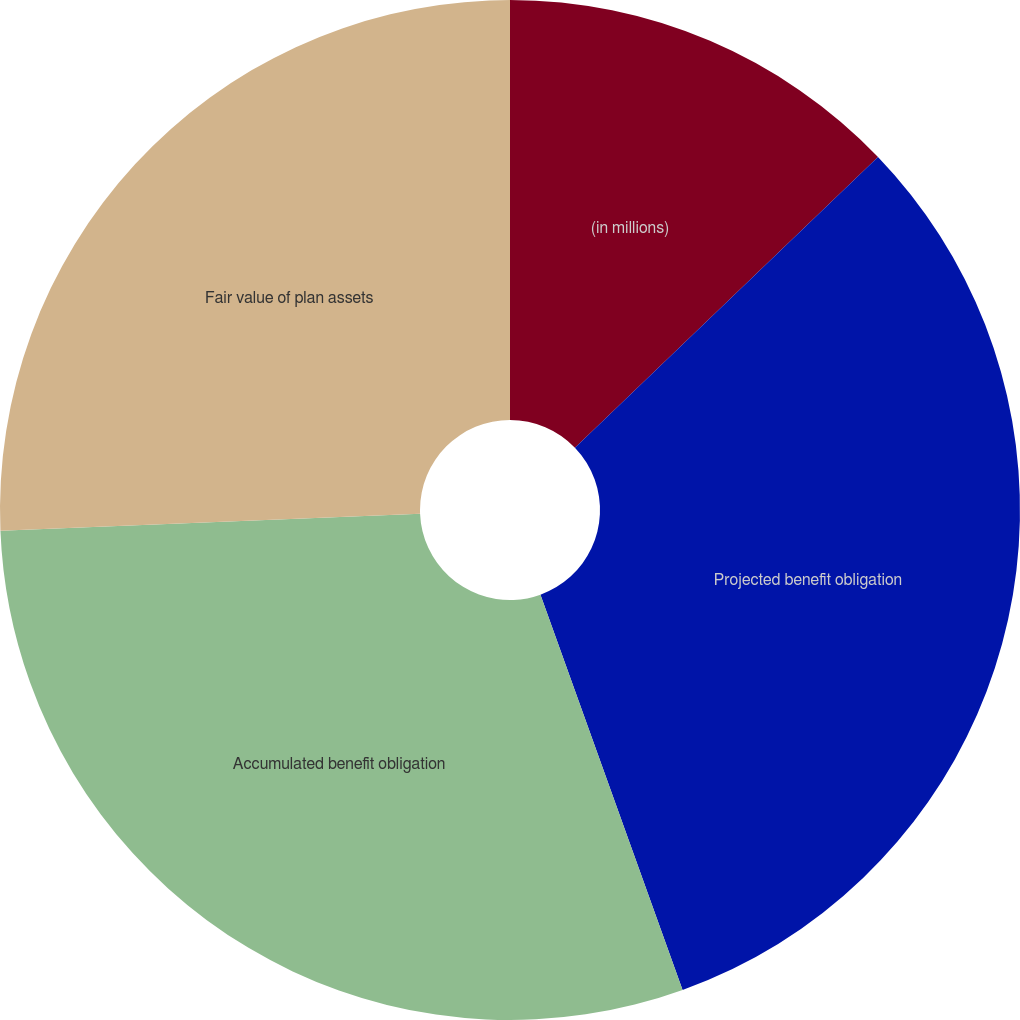Convert chart to OTSL. <chart><loc_0><loc_0><loc_500><loc_500><pie_chart><fcel>(in millions)<fcel>Projected benefit obligation<fcel>Accumulated benefit obligation<fcel>Fair value of plan assets<nl><fcel>12.83%<fcel>31.68%<fcel>29.85%<fcel>25.65%<nl></chart> 